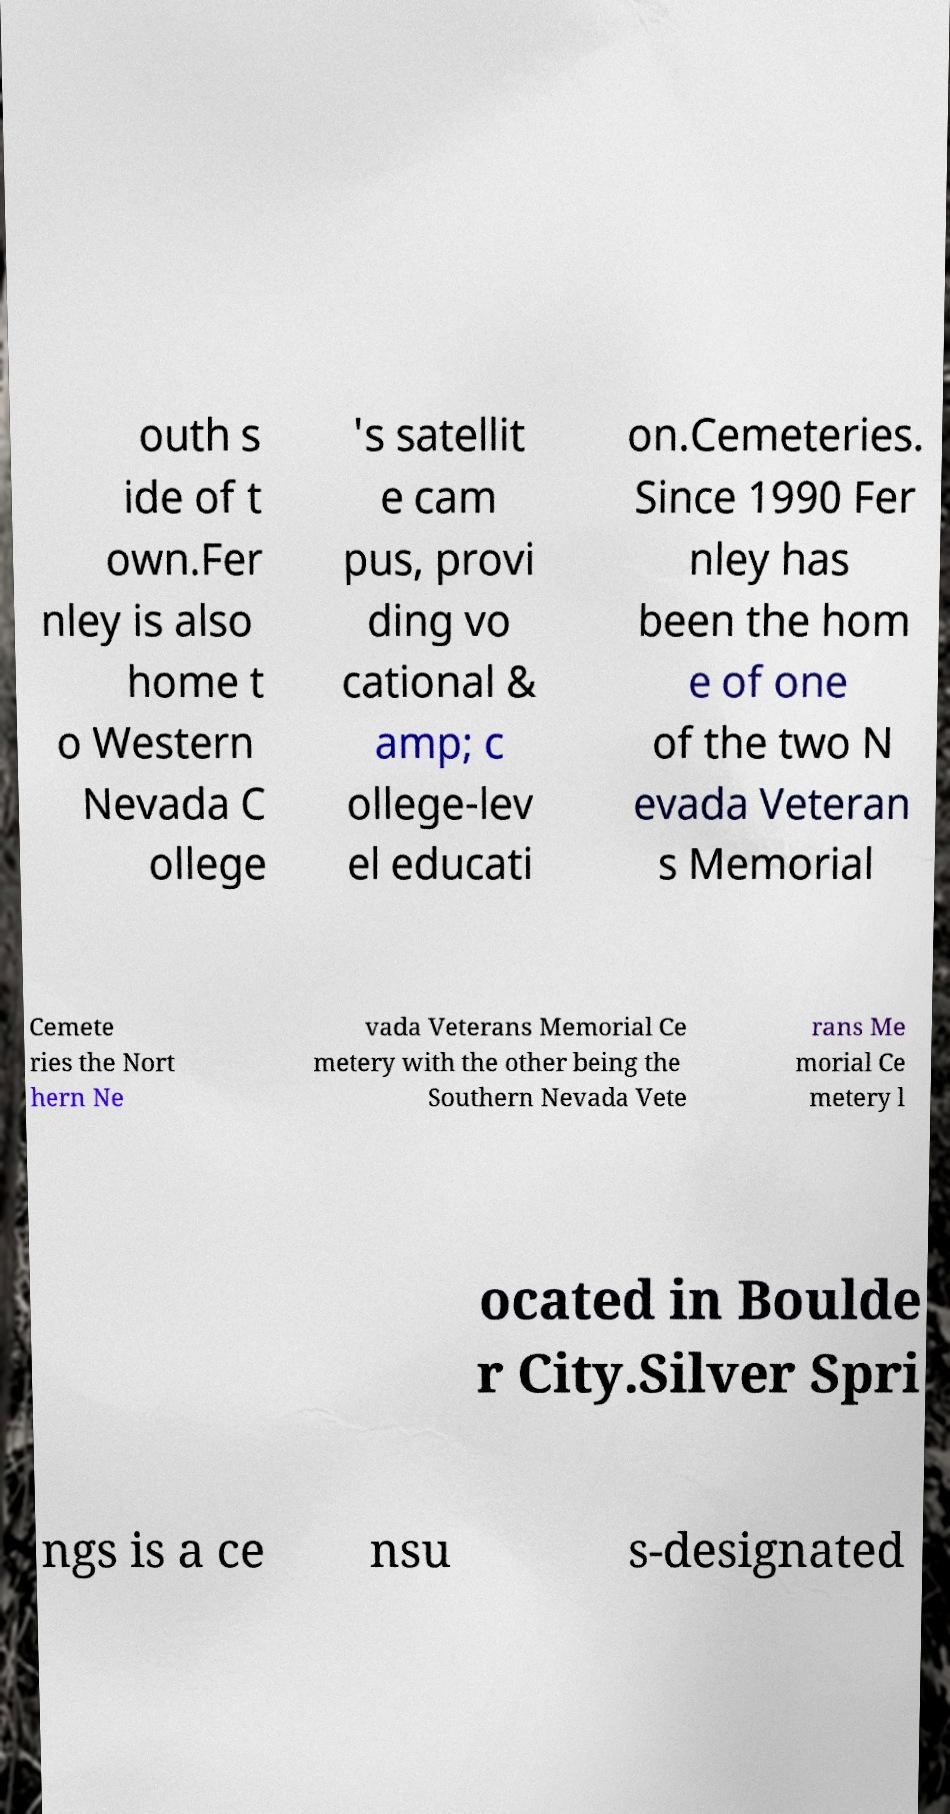Could you extract and type out the text from this image? outh s ide of t own.Fer nley is also home t o Western Nevada C ollege 's satellit e cam pus, provi ding vo cational & amp; c ollege-lev el educati on.Cemeteries. Since 1990 Fer nley has been the hom e of one of the two N evada Veteran s Memorial Cemete ries the Nort hern Ne vada Veterans Memorial Ce metery with the other being the Southern Nevada Vete rans Me morial Ce metery l ocated in Boulde r City.Silver Spri ngs is a ce nsu s-designated 